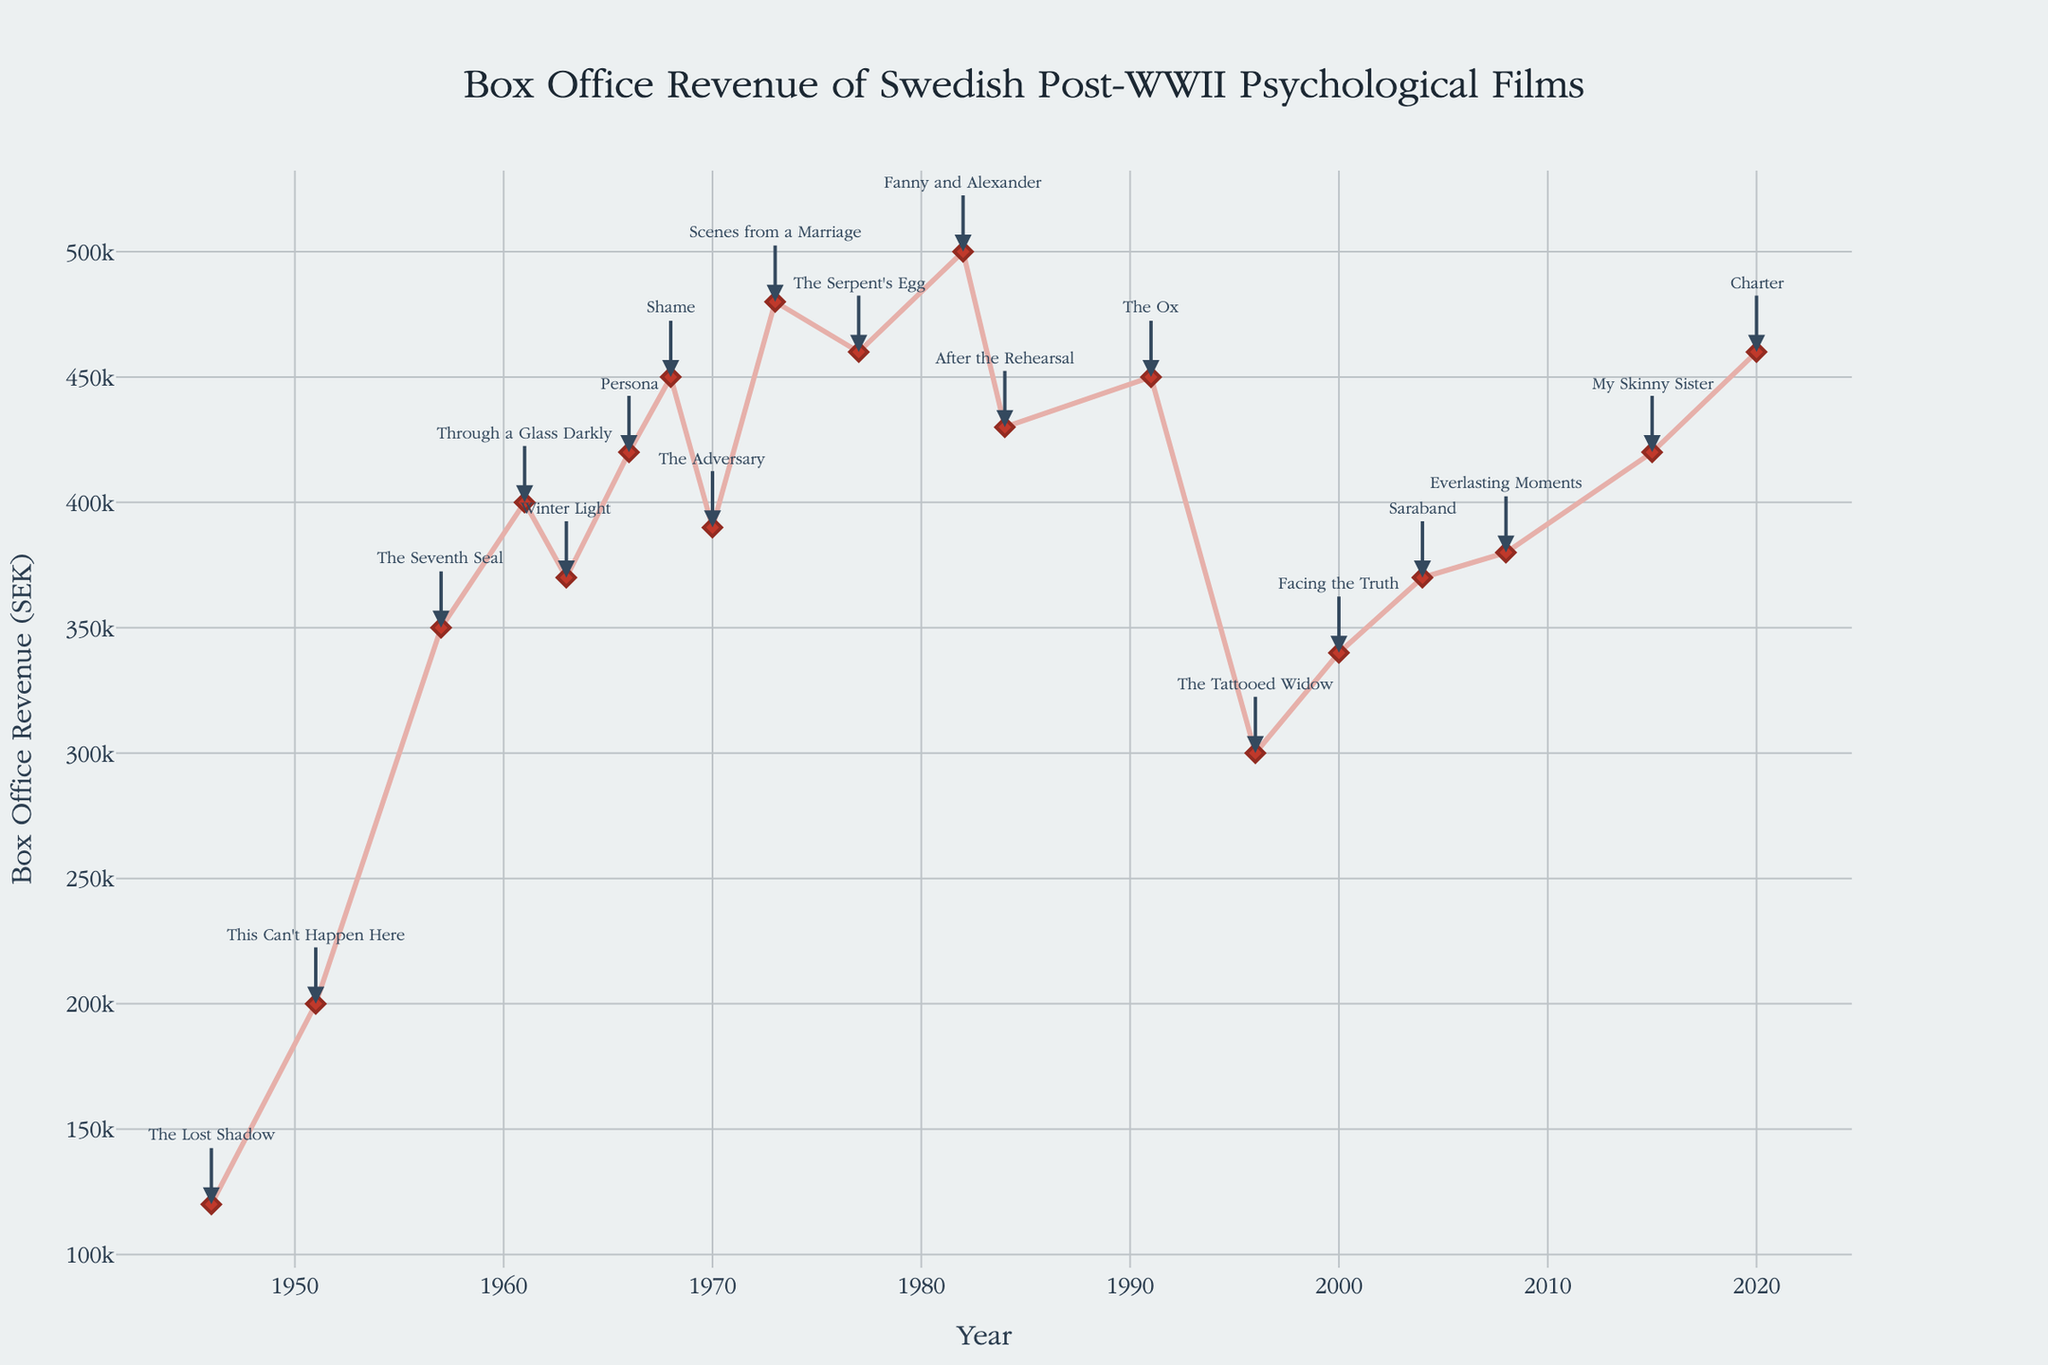What is the highest box office revenue recorded in the plot? First, locate the y-axis labeled "Box Office Revenue (SEK)" to understand the revenue scale. Next, identify the data point that reaches the highest level on this axis. The peak in the plot represents the highest box office revenue.
Answer: 500000 SEK Which film recorded the highest box office revenue? Look for the annotation with the highest arrow on the graph. Check the film title associated with this point; the one that is higher than all others represents the peak.
Answer: Fanny and Alexander What is the average box office revenue for the films released in the 1960s? Identify the data points for the films released in the 1960s: "Through a Glass Darkly" (1961), "Winter Light" (1963), "Persona" (1966), "Shame" (1968). Then, sum up their revenues: 400000 + 370000 + 420000 + 450000 = 1640000 SEK. Finally, divide by the number of films (4): 1640000 / 4 = 410000.
Answer: 410000 SEK How did the box office revenue trend change from the 1950s to the 1970s? Identify the data points from the 1950s ("The Seventh Seal") and the 1970s ("The Adversary," "Scenes from a Marriage," "The Serpent's Egg"). Track their revenues: 350000 (1957), 390000 (1970), 480000 (1973), 460000 (1977). Notice that the general trend from 350000 to a peak of 480000 and then slight drop suggesting a growth trend with minor fluctuations.
Answer: Increased Which director has the most films on this plot? Examine the annotations for film titles and their respective directors. Count the number of films each director has. Ingmar Bergman appears most frequently with multiple films throughout different decades.
Answer: Ingmar Bergman What is the difference in box office revenue between "Persona" (1966) and "Scene from a Marriage" (1973)? Find the points corresponding to "Persona" and "Scenes from a Marriage." Note their revenues: 420000 (1966) and 480000 (1973). Calculate the difference: 480000 - 420000 = 60000 SEK.
Answer: 60000 SEK What is the box office revenue trend from 2010 to 2020? Identify films in the specified range: "My Skinny Sister" (2015) and "Charter" (2020). Check their box office revenues: 420000 (2015) to 460000 (2020). The trend appears to be increasing.
Answer: Increasing Which decade had the most consistent box office performance? Analyze the data points within each decade and observe their proximity to each other. For instance, consider the 1950s, 1960s, 1970s, etc. The revenues in the 2000s ("Facing the Truth" and "Saraband") are relatively close: 340000 and 370000, showing consistency.
Answer: 2000s What is the average box office revenue for all the films in the dataset? Sum all individual revenues and divide by the total number of films: (120000 + 200000 + 350000 + 400000 + 370000 + 420000 + 450000 + 390000 + 480000 + 460000 + 500000 + 430000 + 450000 + 300000 + 340000 + 370000 + 380000 + 420000 + 460000) / 19 ≈ 399474 SEK.
Answer: ~399474 SEK 